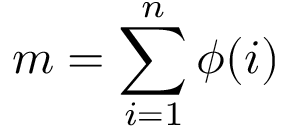<formula> <loc_0><loc_0><loc_500><loc_500>m = \sum _ { i = 1 } ^ { n } \phi ( i )</formula> 